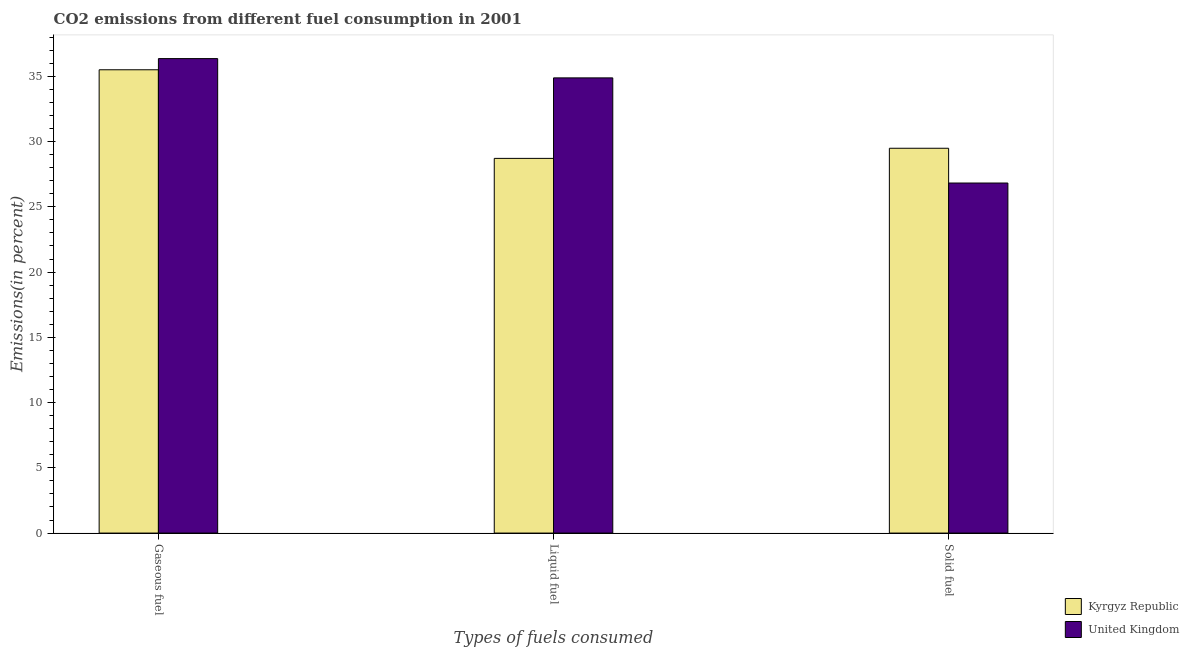How many different coloured bars are there?
Make the answer very short. 2. How many groups of bars are there?
Make the answer very short. 3. Are the number of bars per tick equal to the number of legend labels?
Your answer should be very brief. Yes. Are the number of bars on each tick of the X-axis equal?
Make the answer very short. Yes. What is the label of the 3rd group of bars from the left?
Your answer should be very brief. Solid fuel. What is the percentage of liquid fuel emission in United Kingdom?
Your answer should be compact. 34.88. Across all countries, what is the maximum percentage of gaseous fuel emission?
Make the answer very short. 36.36. Across all countries, what is the minimum percentage of gaseous fuel emission?
Your answer should be very brief. 35.5. In which country was the percentage of solid fuel emission maximum?
Offer a terse response. Kyrgyz Republic. In which country was the percentage of gaseous fuel emission minimum?
Your answer should be very brief. Kyrgyz Republic. What is the total percentage of liquid fuel emission in the graph?
Your response must be concise. 63.59. What is the difference between the percentage of solid fuel emission in United Kingdom and that in Kyrgyz Republic?
Offer a very short reply. -2.66. What is the difference between the percentage of solid fuel emission in Kyrgyz Republic and the percentage of liquid fuel emission in United Kingdom?
Offer a terse response. -5.39. What is the average percentage of solid fuel emission per country?
Keep it short and to the point. 28.15. What is the difference between the percentage of liquid fuel emission and percentage of solid fuel emission in Kyrgyz Republic?
Your response must be concise. -0.78. What is the ratio of the percentage of solid fuel emission in United Kingdom to that in Kyrgyz Republic?
Provide a short and direct response. 0.91. Is the difference between the percentage of liquid fuel emission in United Kingdom and Kyrgyz Republic greater than the difference between the percentage of gaseous fuel emission in United Kingdom and Kyrgyz Republic?
Provide a succinct answer. Yes. What is the difference between the highest and the second highest percentage of liquid fuel emission?
Offer a terse response. 6.17. What is the difference between the highest and the lowest percentage of gaseous fuel emission?
Offer a very short reply. 0.86. What does the 2nd bar from the right in Solid fuel represents?
Provide a short and direct response. Kyrgyz Republic. How many bars are there?
Offer a terse response. 6. How many countries are there in the graph?
Give a very brief answer. 2. What is the difference between two consecutive major ticks on the Y-axis?
Ensure brevity in your answer.  5. Does the graph contain any zero values?
Your answer should be very brief. No. Where does the legend appear in the graph?
Provide a succinct answer. Bottom right. What is the title of the graph?
Make the answer very short. CO2 emissions from different fuel consumption in 2001. Does "Korea (Democratic)" appear as one of the legend labels in the graph?
Your answer should be compact. No. What is the label or title of the X-axis?
Ensure brevity in your answer.  Types of fuels consumed. What is the label or title of the Y-axis?
Your response must be concise. Emissions(in percent). What is the Emissions(in percent) in Kyrgyz Republic in Gaseous fuel?
Provide a short and direct response. 35.5. What is the Emissions(in percent) of United Kingdom in Gaseous fuel?
Offer a terse response. 36.36. What is the Emissions(in percent) of Kyrgyz Republic in Liquid fuel?
Give a very brief answer. 28.71. What is the Emissions(in percent) of United Kingdom in Liquid fuel?
Ensure brevity in your answer.  34.88. What is the Emissions(in percent) in Kyrgyz Republic in Solid fuel?
Ensure brevity in your answer.  29.49. What is the Emissions(in percent) in United Kingdom in Solid fuel?
Keep it short and to the point. 26.82. Across all Types of fuels consumed, what is the maximum Emissions(in percent) of Kyrgyz Republic?
Keep it short and to the point. 35.5. Across all Types of fuels consumed, what is the maximum Emissions(in percent) of United Kingdom?
Provide a succinct answer. 36.36. Across all Types of fuels consumed, what is the minimum Emissions(in percent) in Kyrgyz Republic?
Provide a short and direct response. 28.71. Across all Types of fuels consumed, what is the minimum Emissions(in percent) of United Kingdom?
Your answer should be very brief. 26.82. What is the total Emissions(in percent) of Kyrgyz Republic in the graph?
Offer a very short reply. 93.7. What is the total Emissions(in percent) in United Kingdom in the graph?
Provide a succinct answer. 98.06. What is the difference between the Emissions(in percent) of Kyrgyz Republic in Gaseous fuel and that in Liquid fuel?
Provide a succinct answer. 6.79. What is the difference between the Emissions(in percent) in United Kingdom in Gaseous fuel and that in Liquid fuel?
Provide a succinct answer. 1.48. What is the difference between the Emissions(in percent) of Kyrgyz Republic in Gaseous fuel and that in Solid fuel?
Make the answer very short. 6.01. What is the difference between the Emissions(in percent) of United Kingdom in Gaseous fuel and that in Solid fuel?
Offer a terse response. 9.53. What is the difference between the Emissions(in percent) of Kyrgyz Republic in Liquid fuel and that in Solid fuel?
Provide a succinct answer. -0.78. What is the difference between the Emissions(in percent) of United Kingdom in Liquid fuel and that in Solid fuel?
Give a very brief answer. 8.06. What is the difference between the Emissions(in percent) in Kyrgyz Republic in Gaseous fuel and the Emissions(in percent) in United Kingdom in Liquid fuel?
Your response must be concise. 0.62. What is the difference between the Emissions(in percent) in Kyrgyz Republic in Gaseous fuel and the Emissions(in percent) in United Kingdom in Solid fuel?
Keep it short and to the point. 8.68. What is the difference between the Emissions(in percent) in Kyrgyz Republic in Liquid fuel and the Emissions(in percent) in United Kingdom in Solid fuel?
Offer a terse response. 1.89. What is the average Emissions(in percent) in Kyrgyz Republic per Types of fuels consumed?
Offer a very short reply. 31.23. What is the average Emissions(in percent) in United Kingdom per Types of fuels consumed?
Offer a terse response. 32.69. What is the difference between the Emissions(in percent) of Kyrgyz Republic and Emissions(in percent) of United Kingdom in Gaseous fuel?
Give a very brief answer. -0.86. What is the difference between the Emissions(in percent) of Kyrgyz Republic and Emissions(in percent) of United Kingdom in Liquid fuel?
Your response must be concise. -6.17. What is the difference between the Emissions(in percent) of Kyrgyz Republic and Emissions(in percent) of United Kingdom in Solid fuel?
Provide a succinct answer. 2.66. What is the ratio of the Emissions(in percent) of Kyrgyz Republic in Gaseous fuel to that in Liquid fuel?
Ensure brevity in your answer.  1.24. What is the ratio of the Emissions(in percent) in United Kingdom in Gaseous fuel to that in Liquid fuel?
Your answer should be very brief. 1.04. What is the ratio of the Emissions(in percent) in Kyrgyz Republic in Gaseous fuel to that in Solid fuel?
Provide a short and direct response. 1.2. What is the ratio of the Emissions(in percent) of United Kingdom in Gaseous fuel to that in Solid fuel?
Offer a terse response. 1.36. What is the ratio of the Emissions(in percent) of Kyrgyz Republic in Liquid fuel to that in Solid fuel?
Provide a short and direct response. 0.97. What is the ratio of the Emissions(in percent) of United Kingdom in Liquid fuel to that in Solid fuel?
Provide a short and direct response. 1.3. What is the difference between the highest and the second highest Emissions(in percent) in Kyrgyz Republic?
Your response must be concise. 6.01. What is the difference between the highest and the second highest Emissions(in percent) in United Kingdom?
Ensure brevity in your answer.  1.48. What is the difference between the highest and the lowest Emissions(in percent) in Kyrgyz Republic?
Provide a succinct answer. 6.79. What is the difference between the highest and the lowest Emissions(in percent) of United Kingdom?
Your answer should be very brief. 9.53. 